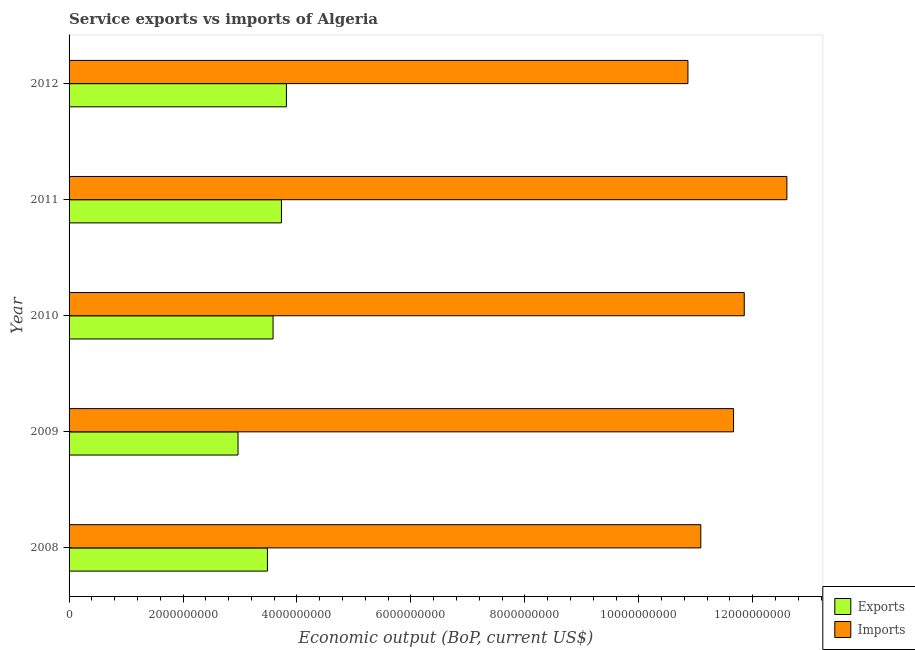Are the number of bars on each tick of the Y-axis equal?
Make the answer very short. Yes. How many bars are there on the 3rd tick from the bottom?
Provide a short and direct response. 2. What is the label of the 4th group of bars from the top?
Give a very brief answer. 2009. What is the amount of service exports in 2010?
Provide a succinct answer. 3.58e+09. Across all years, what is the maximum amount of service exports?
Ensure brevity in your answer.  3.82e+09. Across all years, what is the minimum amount of service imports?
Provide a short and direct response. 1.09e+1. In which year was the amount of service exports minimum?
Keep it short and to the point. 2009. What is the total amount of service imports in the graph?
Your answer should be compact. 5.81e+1. What is the difference between the amount of service imports in 2010 and that in 2011?
Ensure brevity in your answer.  -7.49e+08. What is the difference between the amount of service exports in 2012 and the amount of service imports in 2008?
Offer a terse response. -7.27e+09. What is the average amount of service exports per year?
Ensure brevity in your answer.  3.51e+09. In the year 2009, what is the difference between the amount of service imports and amount of service exports?
Provide a succinct answer. 8.70e+09. What is the ratio of the amount of service exports in 2008 to that in 2009?
Offer a terse response. 1.17. Is the amount of service exports in 2008 less than that in 2012?
Offer a terse response. Yes. What is the difference between the highest and the second highest amount of service imports?
Your response must be concise. 7.49e+08. What is the difference between the highest and the lowest amount of service imports?
Provide a succinct answer. 1.74e+09. In how many years, is the amount of service exports greater than the average amount of service exports taken over all years?
Provide a short and direct response. 3. Is the sum of the amount of service imports in 2010 and 2012 greater than the maximum amount of service exports across all years?
Offer a very short reply. Yes. What does the 1st bar from the top in 2012 represents?
Your response must be concise. Imports. What does the 2nd bar from the bottom in 2008 represents?
Provide a succinct answer. Imports. How many bars are there?
Provide a succinct answer. 10. How many years are there in the graph?
Give a very brief answer. 5. What is the difference between two consecutive major ticks on the X-axis?
Provide a succinct answer. 2.00e+09. What is the title of the graph?
Your answer should be very brief. Service exports vs imports of Algeria. What is the label or title of the X-axis?
Your answer should be compact. Economic output (BoP, current US$). What is the Economic output (BoP, current US$) of Exports in 2008?
Ensure brevity in your answer.  3.48e+09. What is the Economic output (BoP, current US$) in Imports in 2008?
Provide a short and direct response. 1.11e+1. What is the Economic output (BoP, current US$) in Exports in 2009?
Keep it short and to the point. 2.97e+09. What is the Economic output (BoP, current US$) of Imports in 2009?
Provide a succinct answer. 1.17e+1. What is the Economic output (BoP, current US$) in Exports in 2010?
Your answer should be very brief. 3.58e+09. What is the Economic output (BoP, current US$) of Imports in 2010?
Keep it short and to the point. 1.19e+1. What is the Economic output (BoP, current US$) in Exports in 2011?
Make the answer very short. 3.73e+09. What is the Economic output (BoP, current US$) of Imports in 2011?
Keep it short and to the point. 1.26e+1. What is the Economic output (BoP, current US$) in Exports in 2012?
Keep it short and to the point. 3.82e+09. What is the Economic output (BoP, current US$) of Imports in 2012?
Give a very brief answer. 1.09e+1. Across all years, what is the maximum Economic output (BoP, current US$) of Exports?
Offer a very short reply. 3.82e+09. Across all years, what is the maximum Economic output (BoP, current US$) of Imports?
Make the answer very short. 1.26e+1. Across all years, what is the minimum Economic output (BoP, current US$) of Exports?
Make the answer very short. 2.97e+09. Across all years, what is the minimum Economic output (BoP, current US$) in Imports?
Your answer should be compact. 1.09e+1. What is the total Economic output (BoP, current US$) of Exports in the graph?
Your answer should be compact. 1.76e+1. What is the total Economic output (BoP, current US$) in Imports in the graph?
Ensure brevity in your answer.  5.81e+1. What is the difference between the Economic output (BoP, current US$) of Exports in 2008 and that in 2009?
Offer a very short reply. 5.16e+08. What is the difference between the Economic output (BoP, current US$) in Imports in 2008 and that in 2009?
Provide a short and direct response. -5.75e+08. What is the difference between the Economic output (BoP, current US$) in Exports in 2008 and that in 2010?
Your response must be concise. -9.86e+07. What is the difference between the Economic output (BoP, current US$) of Imports in 2008 and that in 2010?
Your response must be concise. -7.63e+08. What is the difference between the Economic output (BoP, current US$) of Exports in 2008 and that in 2011?
Offer a terse response. -2.46e+08. What is the difference between the Economic output (BoP, current US$) of Imports in 2008 and that in 2011?
Provide a short and direct response. -1.51e+09. What is the difference between the Economic output (BoP, current US$) of Exports in 2008 and that in 2012?
Give a very brief answer. -3.33e+08. What is the difference between the Economic output (BoP, current US$) in Imports in 2008 and that in 2012?
Offer a terse response. 2.26e+08. What is the difference between the Economic output (BoP, current US$) in Exports in 2009 and that in 2010?
Your answer should be very brief. -6.15e+08. What is the difference between the Economic output (BoP, current US$) in Imports in 2009 and that in 2010?
Provide a short and direct response. -1.88e+08. What is the difference between the Economic output (BoP, current US$) in Exports in 2009 and that in 2011?
Give a very brief answer. -7.62e+08. What is the difference between the Economic output (BoP, current US$) in Imports in 2009 and that in 2011?
Give a very brief answer. -9.36e+08. What is the difference between the Economic output (BoP, current US$) of Exports in 2009 and that in 2012?
Ensure brevity in your answer.  -8.50e+08. What is the difference between the Economic output (BoP, current US$) in Imports in 2009 and that in 2012?
Your answer should be very brief. 8.00e+08. What is the difference between the Economic output (BoP, current US$) in Exports in 2010 and that in 2011?
Your answer should be very brief. -1.47e+08. What is the difference between the Economic output (BoP, current US$) of Imports in 2010 and that in 2011?
Provide a succinct answer. -7.49e+08. What is the difference between the Economic output (BoP, current US$) in Exports in 2010 and that in 2012?
Make the answer very short. -2.35e+08. What is the difference between the Economic output (BoP, current US$) of Imports in 2010 and that in 2012?
Give a very brief answer. 9.88e+08. What is the difference between the Economic output (BoP, current US$) of Exports in 2011 and that in 2012?
Provide a succinct answer. -8.75e+07. What is the difference between the Economic output (BoP, current US$) of Imports in 2011 and that in 2012?
Your answer should be very brief. 1.74e+09. What is the difference between the Economic output (BoP, current US$) of Exports in 2008 and the Economic output (BoP, current US$) of Imports in 2009?
Your answer should be very brief. -8.18e+09. What is the difference between the Economic output (BoP, current US$) of Exports in 2008 and the Economic output (BoP, current US$) of Imports in 2010?
Make the answer very short. -8.37e+09. What is the difference between the Economic output (BoP, current US$) of Exports in 2008 and the Economic output (BoP, current US$) of Imports in 2011?
Your answer should be very brief. -9.12e+09. What is the difference between the Economic output (BoP, current US$) in Exports in 2008 and the Economic output (BoP, current US$) in Imports in 2012?
Ensure brevity in your answer.  -7.38e+09. What is the difference between the Economic output (BoP, current US$) of Exports in 2009 and the Economic output (BoP, current US$) of Imports in 2010?
Your answer should be very brief. -8.89e+09. What is the difference between the Economic output (BoP, current US$) of Exports in 2009 and the Economic output (BoP, current US$) of Imports in 2011?
Give a very brief answer. -9.63e+09. What is the difference between the Economic output (BoP, current US$) of Exports in 2009 and the Economic output (BoP, current US$) of Imports in 2012?
Make the answer very short. -7.90e+09. What is the difference between the Economic output (BoP, current US$) in Exports in 2010 and the Economic output (BoP, current US$) in Imports in 2011?
Give a very brief answer. -9.02e+09. What is the difference between the Economic output (BoP, current US$) in Exports in 2010 and the Economic output (BoP, current US$) in Imports in 2012?
Provide a succinct answer. -7.28e+09. What is the difference between the Economic output (BoP, current US$) in Exports in 2011 and the Economic output (BoP, current US$) in Imports in 2012?
Provide a succinct answer. -7.13e+09. What is the average Economic output (BoP, current US$) of Exports per year?
Ensure brevity in your answer.  3.51e+09. What is the average Economic output (BoP, current US$) in Imports per year?
Your response must be concise. 1.16e+1. In the year 2008, what is the difference between the Economic output (BoP, current US$) of Exports and Economic output (BoP, current US$) of Imports?
Your response must be concise. -7.61e+09. In the year 2009, what is the difference between the Economic output (BoP, current US$) in Exports and Economic output (BoP, current US$) in Imports?
Your answer should be compact. -8.70e+09. In the year 2010, what is the difference between the Economic output (BoP, current US$) in Exports and Economic output (BoP, current US$) in Imports?
Your response must be concise. -8.27e+09. In the year 2011, what is the difference between the Economic output (BoP, current US$) in Exports and Economic output (BoP, current US$) in Imports?
Provide a succinct answer. -8.87e+09. In the year 2012, what is the difference between the Economic output (BoP, current US$) of Exports and Economic output (BoP, current US$) of Imports?
Ensure brevity in your answer.  -7.05e+09. What is the ratio of the Economic output (BoP, current US$) in Exports in 2008 to that in 2009?
Offer a terse response. 1.17. What is the ratio of the Economic output (BoP, current US$) of Imports in 2008 to that in 2009?
Make the answer very short. 0.95. What is the ratio of the Economic output (BoP, current US$) in Exports in 2008 to that in 2010?
Ensure brevity in your answer.  0.97. What is the ratio of the Economic output (BoP, current US$) in Imports in 2008 to that in 2010?
Offer a terse response. 0.94. What is the ratio of the Economic output (BoP, current US$) of Exports in 2008 to that in 2011?
Keep it short and to the point. 0.93. What is the ratio of the Economic output (BoP, current US$) in Exports in 2008 to that in 2012?
Your response must be concise. 0.91. What is the ratio of the Economic output (BoP, current US$) in Imports in 2008 to that in 2012?
Offer a terse response. 1.02. What is the ratio of the Economic output (BoP, current US$) in Exports in 2009 to that in 2010?
Give a very brief answer. 0.83. What is the ratio of the Economic output (BoP, current US$) of Imports in 2009 to that in 2010?
Offer a very short reply. 0.98. What is the ratio of the Economic output (BoP, current US$) of Exports in 2009 to that in 2011?
Provide a short and direct response. 0.8. What is the ratio of the Economic output (BoP, current US$) in Imports in 2009 to that in 2011?
Make the answer very short. 0.93. What is the ratio of the Economic output (BoP, current US$) of Exports in 2009 to that in 2012?
Your answer should be very brief. 0.78. What is the ratio of the Economic output (BoP, current US$) of Imports in 2009 to that in 2012?
Provide a short and direct response. 1.07. What is the ratio of the Economic output (BoP, current US$) in Exports in 2010 to that in 2011?
Ensure brevity in your answer.  0.96. What is the ratio of the Economic output (BoP, current US$) in Imports in 2010 to that in 2011?
Provide a short and direct response. 0.94. What is the ratio of the Economic output (BoP, current US$) of Exports in 2010 to that in 2012?
Keep it short and to the point. 0.94. What is the ratio of the Economic output (BoP, current US$) of Imports in 2010 to that in 2012?
Your answer should be very brief. 1.09. What is the ratio of the Economic output (BoP, current US$) in Exports in 2011 to that in 2012?
Ensure brevity in your answer.  0.98. What is the ratio of the Economic output (BoP, current US$) in Imports in 2011 to that in 2012?
Offer a very short reply. 1.16. What is the difference between the highest and the second highest Economic output (BoP, current US$) of Exports?
Your response must be concise. 8.75e+07. What is the difference between the highest and the second highest Economic output (BoP, current US$) of Imports?
Provide a short and direct response. 7.49e+08. What is the difference between the highest and the lowest Economic output (BoP, current US$) of Exports?
Your answer should be compact. 8.50e+08. What is the difference between the highest and the lowest Economic output (BoP, current US$) of Imports?
Ensure brevity in your answer.  1.74e+09. 